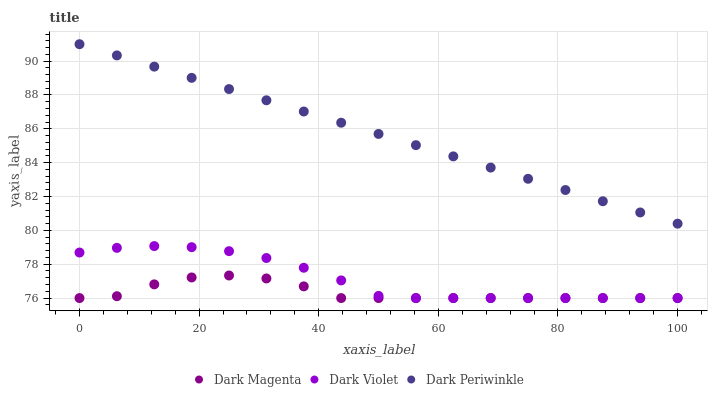Does Dark Magenta have the minimum area under the curve?
Answer yes or no. Yes. Does Dark Periwinkle have the maximum area under the curve?
Answer yes or no. Yes. Does Dark Violet have the minimum area under the curve?
Answer yes or no. No. Does Dark Violet have the maximum area under the curve?
Answer yes or no. No. Is Dark Periwinkle the smoothest?
Answer yes or no. Yes. Is Dark Magenta the roughest?
Answer yes or no. Yes. Is Dark Violet the smoothest?
Answer yes or no. No. Is Dark Violet the roughest?
Answer yes or no. No. Does Dark Magenta have the lowest value?
Answer yes or no. Yes. Does Dark Periwinkle have the lowest value?
Answer yes or no. No. Does Dark Periwinkle have the highest value?
Answer yes or no. Yes. Does Dark Violet have the highest value?
Answer yes or no. No. Is Dark Magenta less than Dark Periwinkle?
Answer yes or no. Yes. Is Dark Periwinkle greater than Dark Magenta?
Answer yes or no. Yes. Does Dark Violet intersect Dark Magenta?
Answer yes or no. Yes. Is Dark Violet less than Dark Magenta?
Answer yes or no. No. Is Dark Violet greater than Dark Magenta?
Answer yes or no. No. Does Dark Magenta intersect Dark Periwinkle?
Answer yes or no. No. 